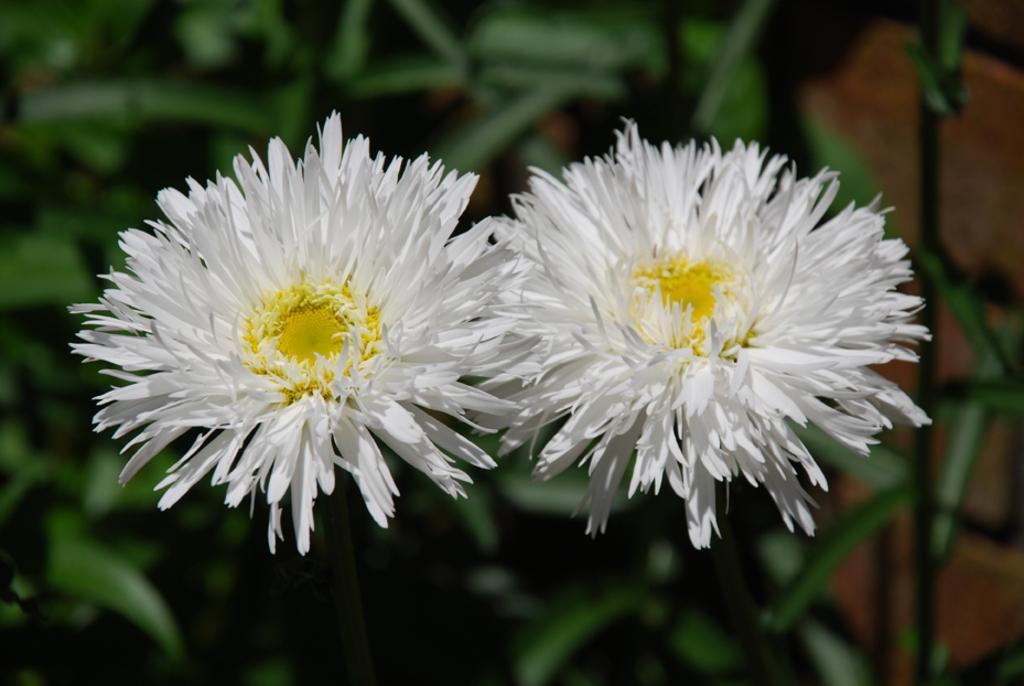Describe this image in one or two sentences. In this picture there are white color flowers on the plant. At the bottom it looks like a ground. 